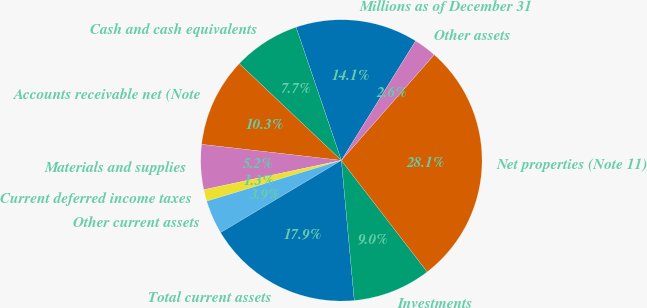<chart> <loc_0><loc_0><loc_500><loc_500><pie_chart><fcel>Millions as of December 31<fcel>Cash and cash equivalents<fcel>Accounts receivable net (Note<fcel>Materials and supplies<fcel>Current deferred income taxes<fcel>Other current assets<fcel>Total current assets<fcel>Investments<fcel>Net properties (Note 11)<fcel>Other assets<nl><fcel>14.07%<fcel>7.71%<fcel>10.25%<fcel>5.16%<fcel>1.34%<fcel>3.89%<fcel>17.89%<fcel>8.98%<fcel>28.08%<fcel>2.62%<nl></chart> 